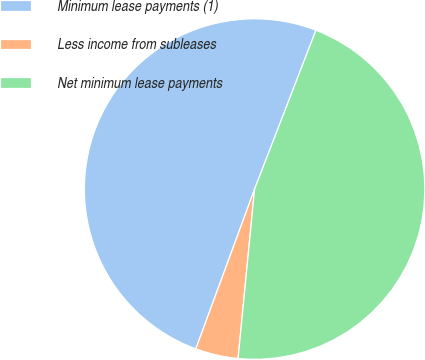Convert chart. <chart><loc_0><loc_0><loc_500><loc_500><pie_chart><fcel>Minimum lease payments (1)<fcel>Less income from subleases<fcel>Net minimum lease payments<nl><fcel>50.25%<fcel>4.06%<fcel>45.68%<nl></chart> 